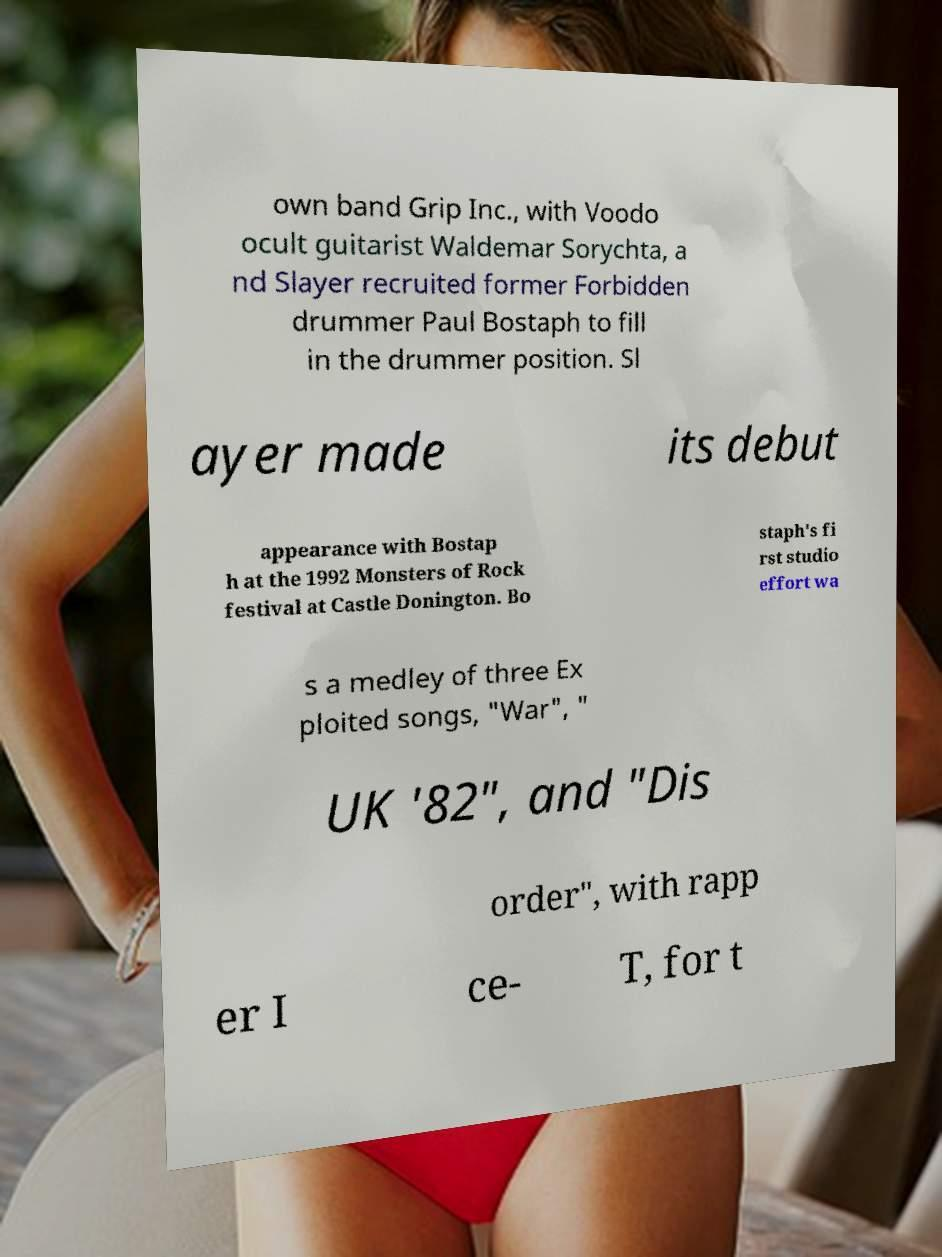Could you assist in decoding the text presented in this image and type it out clearly? own band Grip Inc., with Voodo ocult guitarist Waldemar Sorychta, a nd Slayer recruited former Forbidden drummer Paul Bostaph to fill in the drummer position. Sl ayer made its debut appearance with Bostap h at the 1992 Monsters of Rock festival at Castle Donington. Bo staph's fi rst studio effort wa s a medley of three Ex ploited songs, "War", " UK '82", and "Dis order", with rapp er I ce- T, for t 